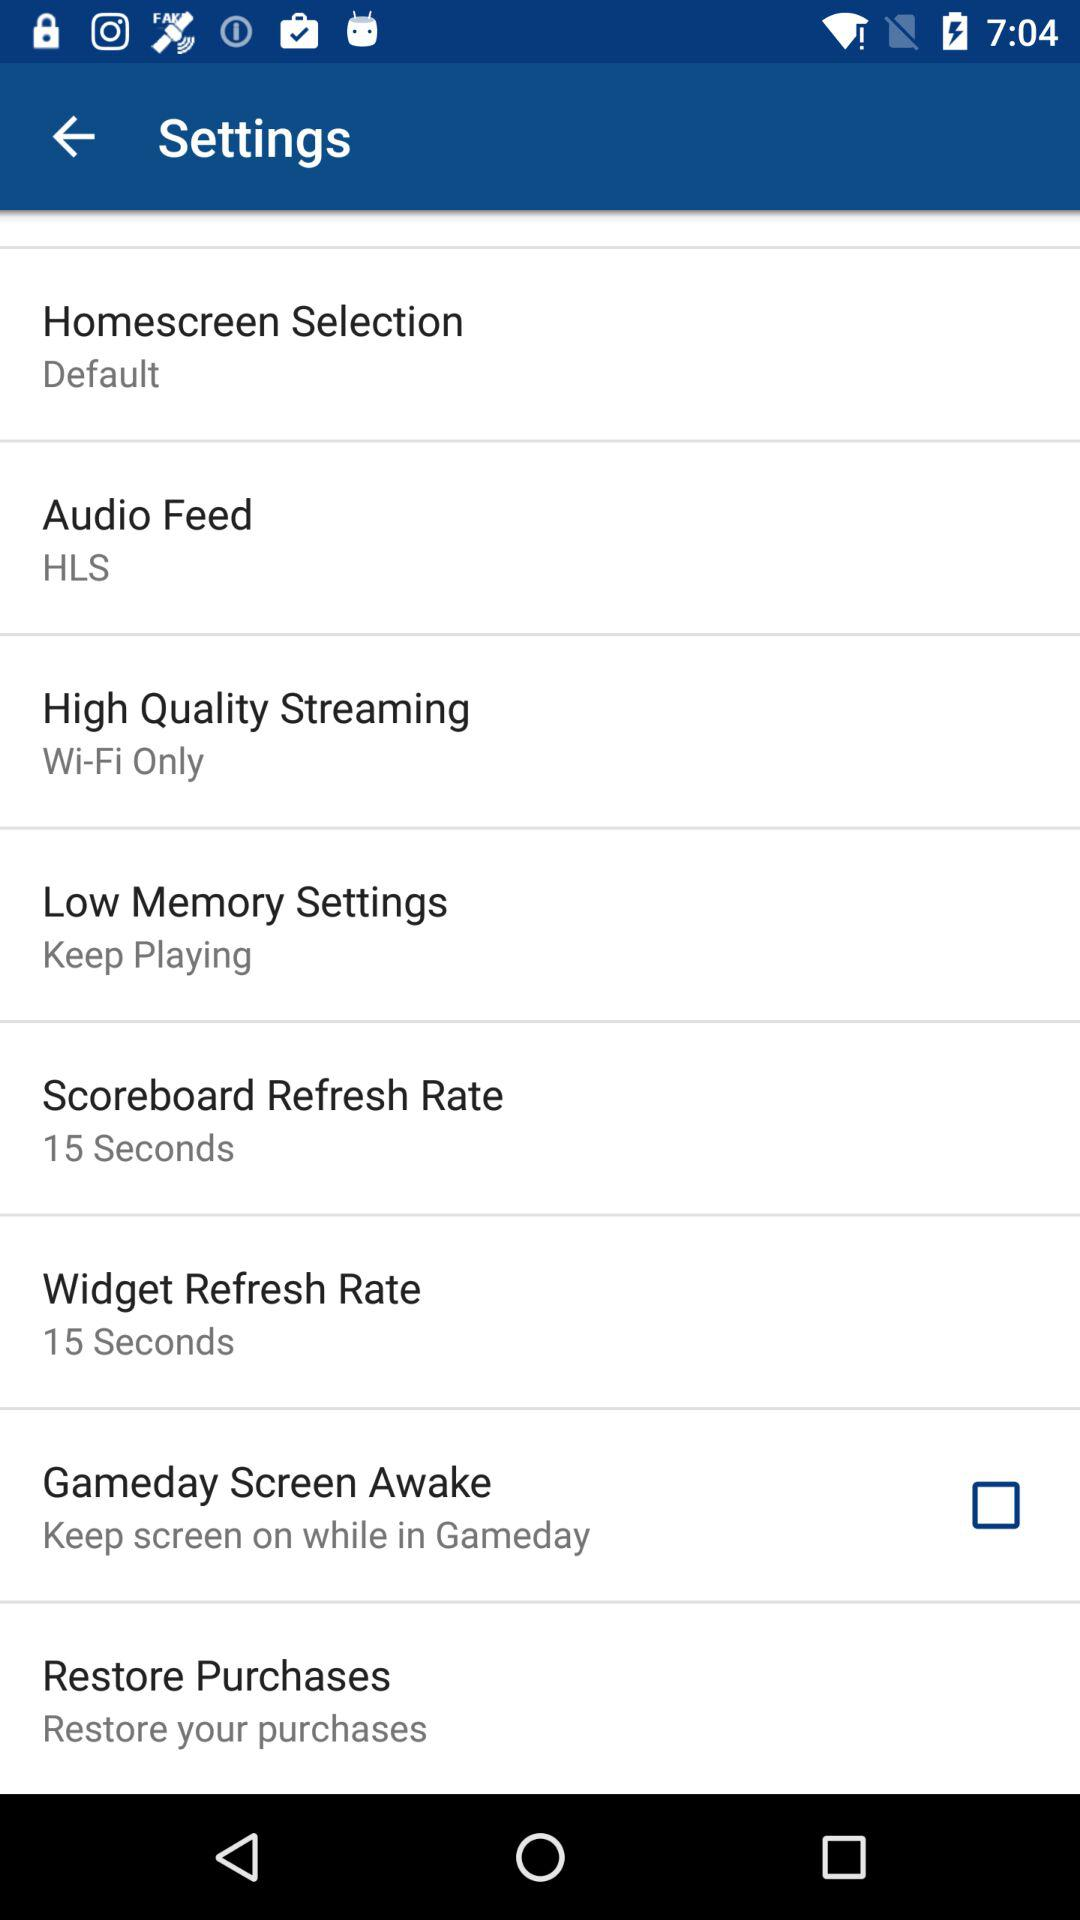What is the setting for "High Quality Streaming"? The setting for "High Quality Streaming" is "Wi-Fi Only". 